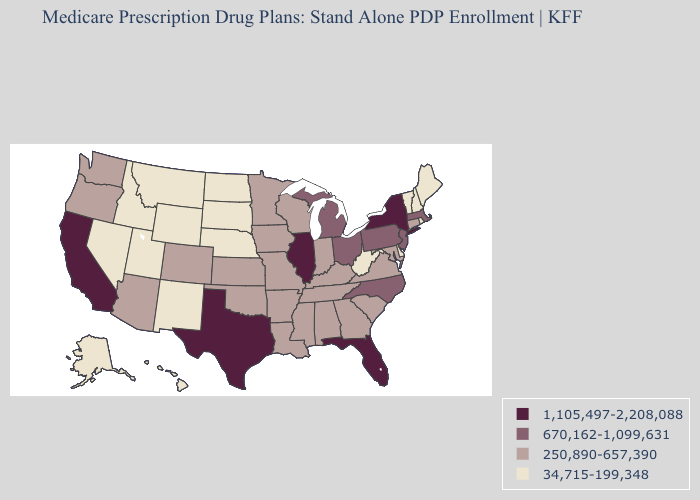What is the value of Kentucky?
Be succinct. 250,890-657,390. What is the highest value in the USA?
Give a very brief answer. 1,105,497-2,208,088. Name the states that have a value in the range 34,715-199,348?
Keep it brief. Alaska, Delaware, Hawaii, Idaho, Maine, Montana, North Dakota, Nebraska, New Hampshire, New Mexico, Nevada, Rhode Island, South Dakota, Utah, Vermont, West Virginia, Wyoming. What is the highest value in states that border New Mexico?
Short answer required. 1,105,497-2,208,088. Does the map have missing data?
Answer briefly. No. Does Minnesota have a lower value than North Carolina?
Concise answer only. Yes. Which states hav the highest value in the West?
Quick response, please. California. Name the states that have a value in the range 250,890-657,390?
Be succinct. Alabama, Arkansas, Arizona, Colorado, Connecticut, Georgia, Iowa, Indiana, Kansas, Kentucky, Louisiana, Maryland, Minnesota, Missouri, Mississippi, Oklahoma, Oregon, South Carolina, Tennessee, Virginia, Washington, Wisconsin. Does Colorado have the highest value in the USA?
Be succinct. No. Name the states that have a value in the range 250,890-657,390?
Concise answer only. Alabama, Arkansas, Arizona, Colorado, Connecticut, Georgia, Iowa, Indiana, Kansas, Kentucky, Louisiana, Maryland, Minnesota, Missouri, Mississippi, Oklahoma, Oregon, South Carolina, Tennessee, Virginia, Washington, Wisconsin. Does Wyoming have the lowest value in the USA?
Quick response, please. Yes. Does Pennsylvania have a lower value than Nebraska?
Concise answer only. No. What is the value of Colorado?
Keep it brief. 250,890-657,390. What is the lowest value in states that border Nebraska?
Write a very short answer. 34,715-199,348. Does the map have missing data?
Be succinct. No. 